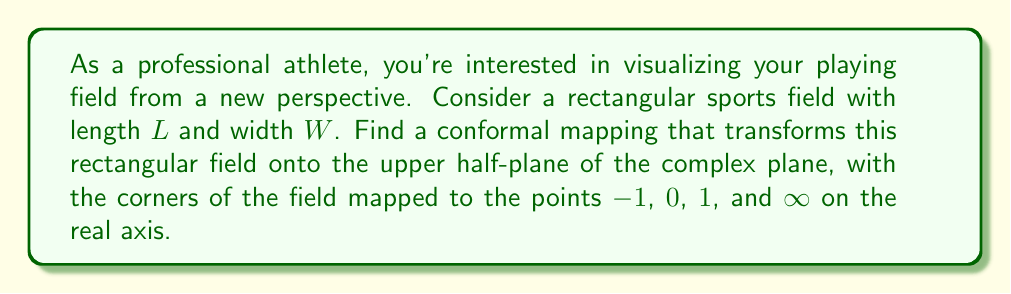Teach me how to tackle this problem. To solve this problem, we'll follow these steps:

1) First, we need to recognize that we're mapping a rectangle to the upper half-plane. A common conformal mapping for this transformation is the Schwarz-Christoffel mapping.

2) The Schwarz-Christoffel mapping for a rectangle to the upper half-plane is given by:

   $$f(z) = A \int_0^z \frac{d\zeta}{\sqrt{(1-\zeta^2)(1-k^2\zeta^2)}} + B$$

   where $A$ and $B$ are complex constants, and $k$ is the modulus of the elliptic function.

3) The modulus $k$ is related to the aspect ratio of the rectangle. For a rectangle with length $L$ and width $W$, $k$ is given by:

   $$k = \frac{\vartheta_2^2(0,q)}{\vartheta_3^2(0,q)}$$

   where $q = e^{-\pi W/L}$ and $\vartheta_2$, $\vartheta_3$ are Jacobi theta functions.

4) The inverse of this mapping is the Jacobi elliptic function $\text{sn}$:

   $$z = \text{sn}(u,k)$$

   where $u = f^{-1}(z)$.

5) To map the corners of the rectangle to $-1$, $0$, $1$, and $\infty$, we need to choose $A$ and $B$ appropriately:

   $$A = \frac{2K(k)}{\pi}, B = -1$$

   where $K(k)$ is the complete elliptic integral of the first kind.

6) Therefore, the final conformal mapping is:

   $$f(z) = \frac{2K(k)}{\pi} \int_0^z \frac{d\zeta}{\sqrt{(1-\zeta^2)(1-k^2\zeta^2)}} - 1$$

This mapping transforms the rectangular sports field onto the upper half-plane, with the corners mapping to the specified points on the real axis.
Answer: The conformal mapping that transforms a rectangular sports field with length $L$ and width $W$ onto the upper half-plane is:

$$f(z) = \frac{2K(k)}{\pi} \int_0^z \frac{d\zeta}{\sqrt{(1-\zeta^2)(1-k^2\zeta^2)}} - 1$$

where $k = \frac{\vartheta_2^2(0,q)}{\vartheta_3^2(0,q)}$, $q = e^{-\pi W/L}$, and $K(k)$ is the complete elliptic integral of the first kind. 